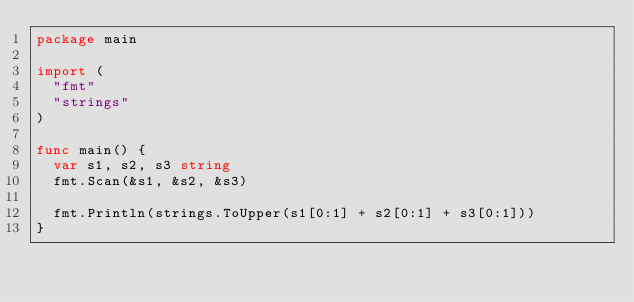Convert code to text. <code><loc_0><loc_0><loc_500><loc_500><_Go_>package main

import (
	"fmt"
	"strings"
)

func main() {
	var s1, s2, s3 string
	fmt.Scan(&s1, &s2, &s3)

	fmt.Println(strings.ToUpper(s1[0:1] + s2[0:1] + s3[0:1]))
}
</code> 